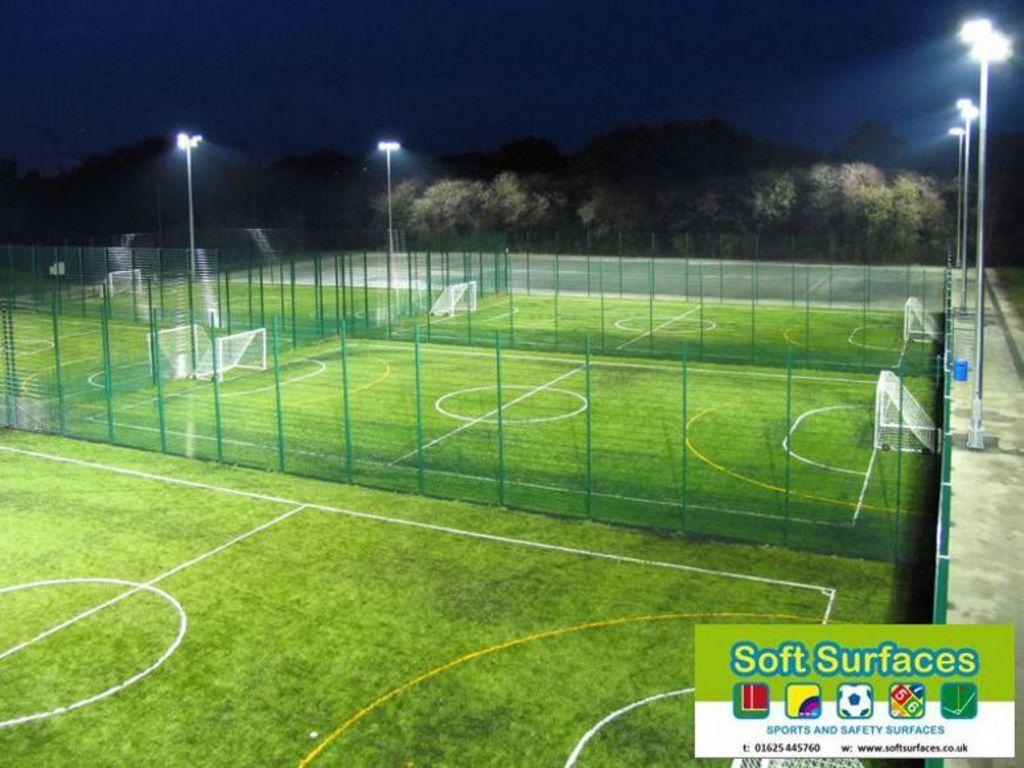Provide a one-sentence caption for the provided image. a field photo that says 'soft surfaces' at the bottom right. 